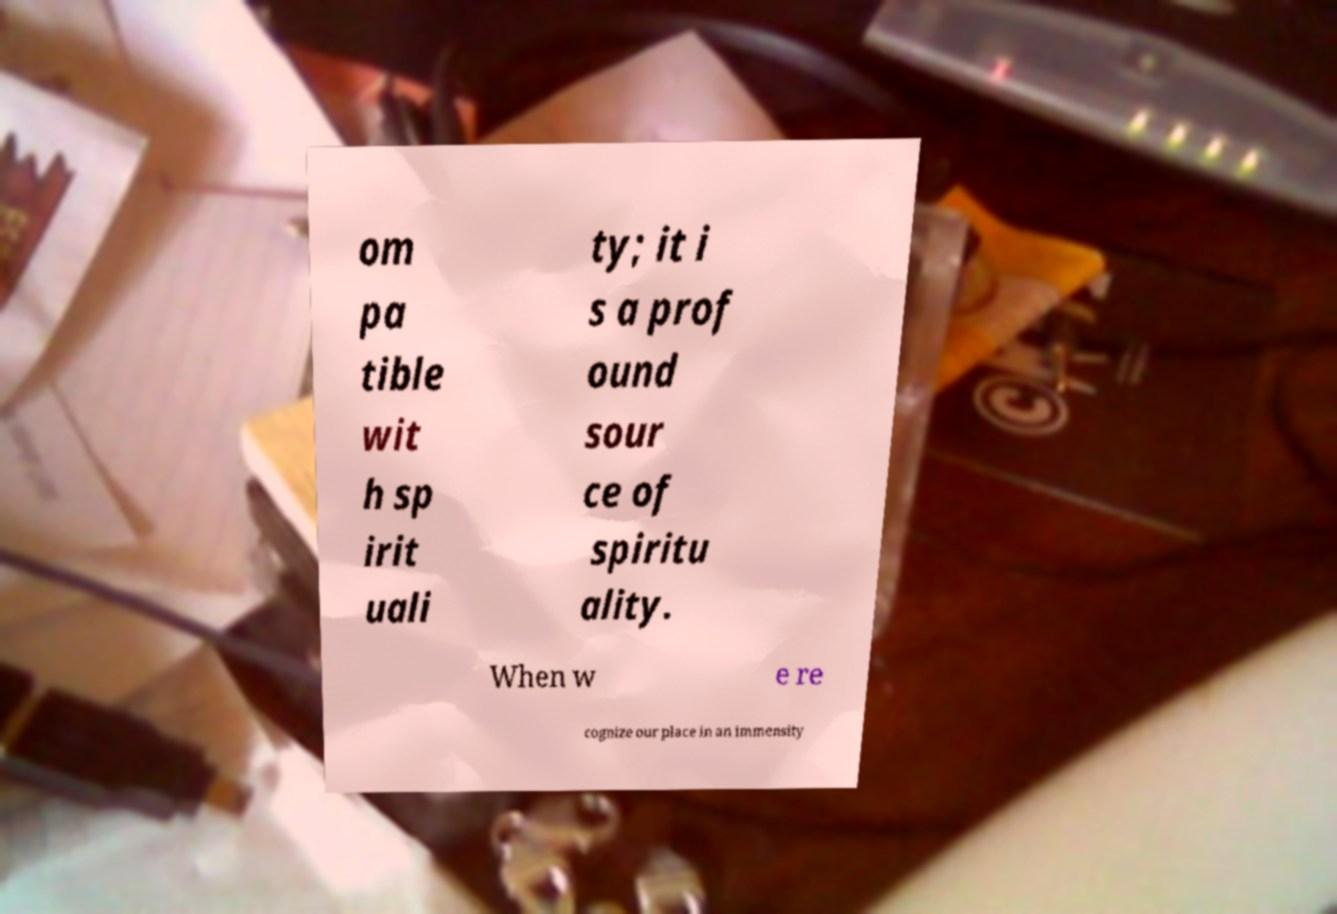What messages or text are displayed in this image? I need them in a readable, typed format. om pa tible wit h sp irit uali ty; it i s a prof ound sour ce of spiritu ality. When w e re cognize our place in an immensity 